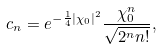<formula> <loc_0><loc_0><loc_500><loc_500>c _ { n } = e ^ { - \frac { 1 } { 4 } | \chi _ { 0 } | ^ { 2 } } \frac { \chi _ { 0 } ^ { n } } { \sqrt { 2 ^ { n } n ! } } ,</formula> 